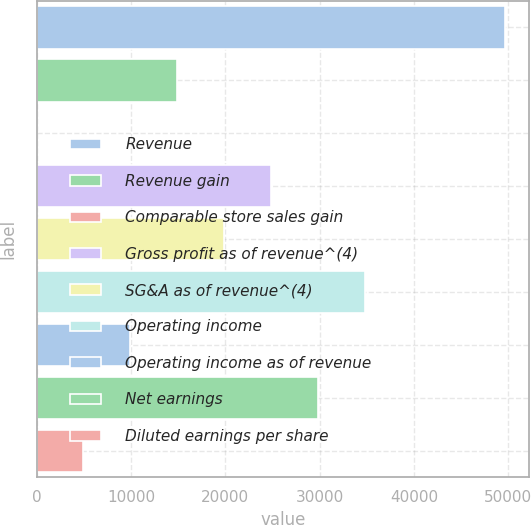Convert chart to OTSL. <chart><loc_0><loc_0><loc_500><loc_500><bar_chart><fcel>Revenue<fcel>Revenue gain<fcel>Comparable store sales gain<fcel>Gross profit as of revenue^(4)<fcel>SG&A as of revenue^(4)<fcel>Operating income<fcel>Operating income as of revenue<fcel>Net earnings<fcel>Diluted earnings per share<nl><fcel>49694<fcel>14908.6<fcel>0.6<fcel>24847.3<fcel>19878<fcel>34786<fcel>9939.28<fcel>29816.6<fcel>4969.94<nl></chart> 